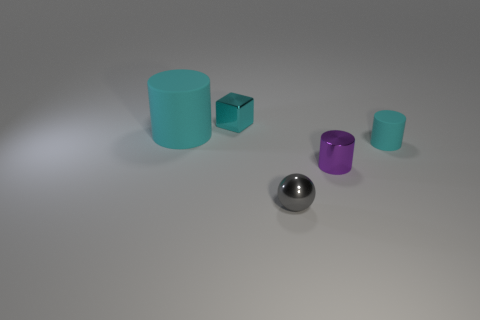What is the shape of the small metallic thing that is the same color as the small matte cylinder?
Your answer should be very brief. Cube. There is a object behind the large cyan thing; how many objects are left of it?
Give a very brief answer. 1. Are there fewer cyan blocks right of the gray object than gray things that are to the left of the cyan metallic object?
Offer a terse response. No. What shape is the rubber thing to the left of the metal object that is on the right side of the small sphere?
Your answer should be compact. Cylinder. How many other objects are the same material as the purple cylinder?
Keep it short and to the point. 2. Is there anything else that has the same size as the ball?
Give a very brief answer. Yes. Is the number of brown cubes greater than the number of big rubber things?
Give a very brief answer. No. There is a shiny object behind the cyan matte cylinder that is in front of the rubber thing that is on the left side of the tiny metallic ball; what size is it?
Your answer should be very brief. Small. There is a gray sphere; is it the same size as the thing that is left of the cyan cube?
Your response must be concise. No. Is the number of tiny gray spheres right of the small gray thing less than the number of purple metallic things?
Make the answer very short. Yes. 